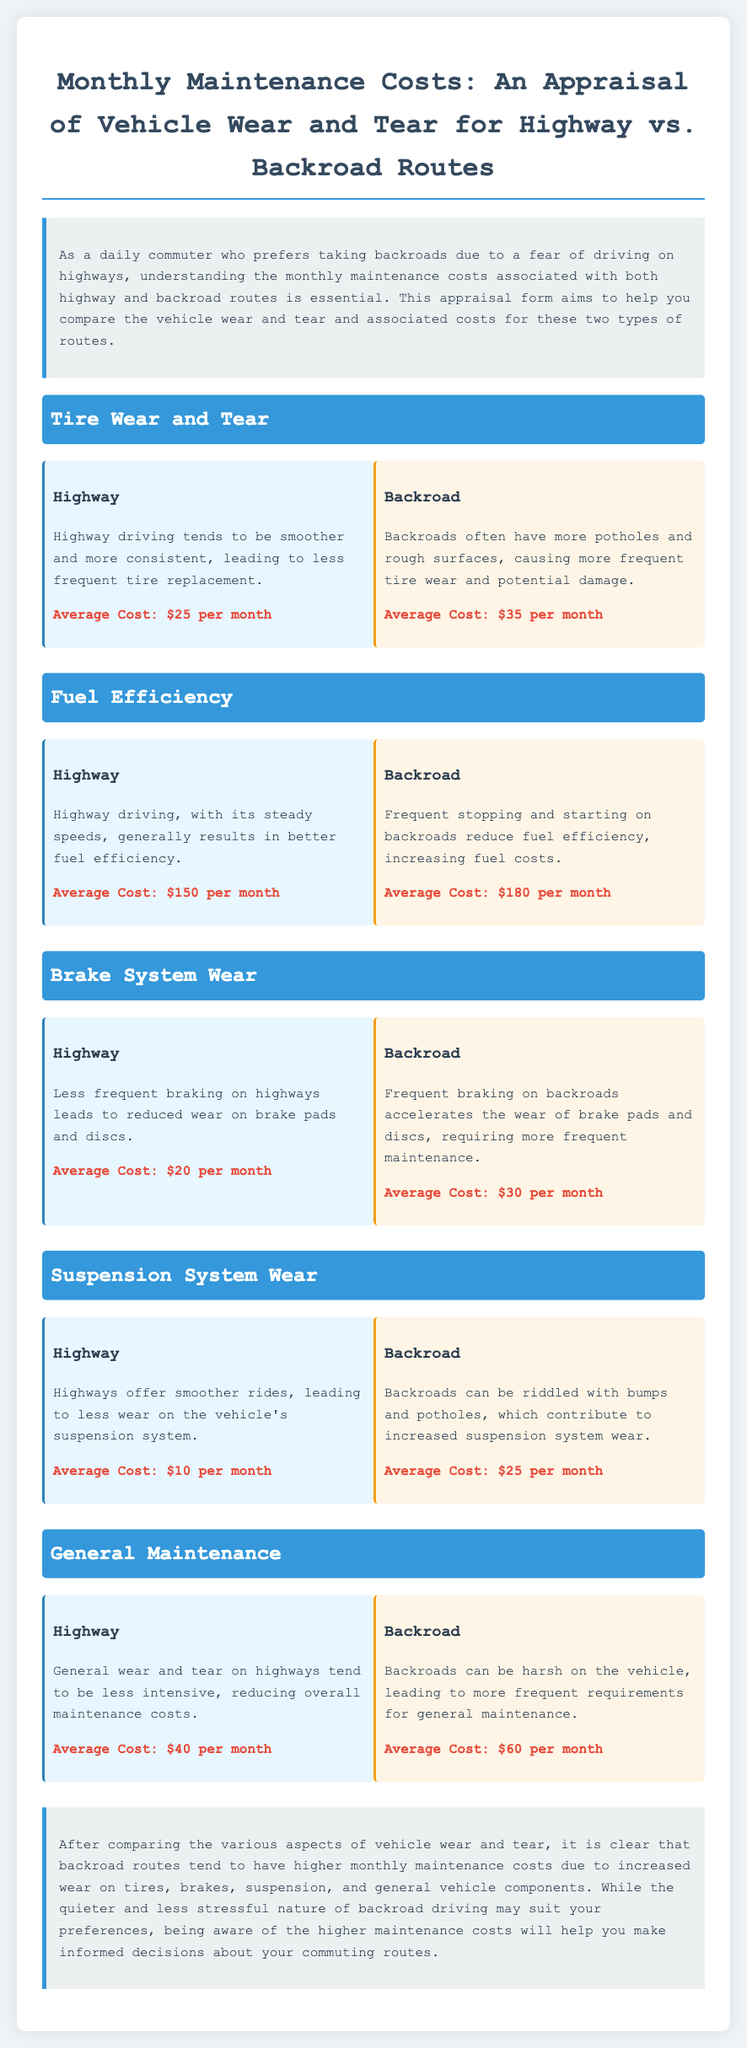What is the average monthly cost for tire wear on highways? The average monthly cost for tire wear on highways is listed in the document as $25 per month.
Answer: $25 per month What is the average monthly fuel cost for backroad driving? The average monthly fuel cost for backroad driving is indicated as $180 per month in the document.
Answer: $180 per month Which driving type results in less brake system wear? The document states that highway driving leads to reduced wear on brake pads and discs due to less frequent braking.
Answer: Highway What is the highest average monthly maintenance cost category for backroads? The highest average monthly maintenance cost category for backroads is general maintenance, which costs $60 per month.
Answer: $60 per month How much more does backroad suspension wear cost compared to highways? The cost difference for suspension system wear between backroads and highways is $15 (backroads $25 - highways $10).
Answer: $15 What is the main reason for higher backroad maintenance costs according to the conclusion? The conclusion states that higher backroad maintenance costs are due to increased wear on tires, brakes, suspension, and general vehicle components.
Answer: Increased wear What kind of driving leads to better fuel efficiency according to the document? The document indicates that highway driving tends to result in better fuel efficiency due to steady speeds.
Answer: Highway What is the total monthly cost of average highway maintenance? The total monthly maintenance cost for highways is calculated by adding all costs: $25 (Tire) + $150 (Fuel) + $20 (Brakes) + $10 (Suspension) + $40 (General) = $245.
Answer: $245 What is the average cost for brake system wear on highways? The average cost for brake system wear mentioned for highways is $20 per month.
Answer: $20 per month 